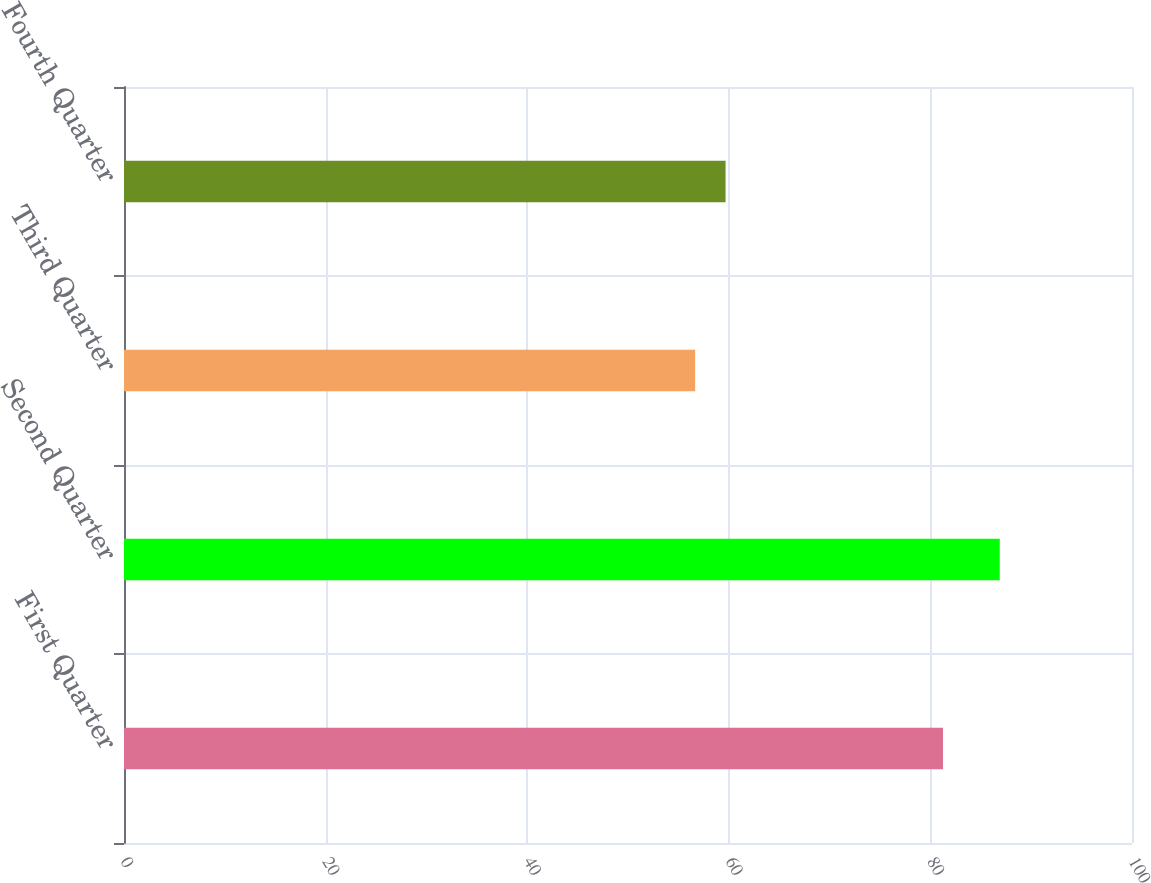Convert chart to OTSL. <chart><loc_0><loc_0><loc_500><loc_500><bar_chart><fcel>First Quarter<fcel>Second Quarter<fcel>Third Quarter<fcel>Fourth Quarter<nl><fcel>81.25<fcel>86.88<fcel>56.66<fcel>59.68<nl></chart> 